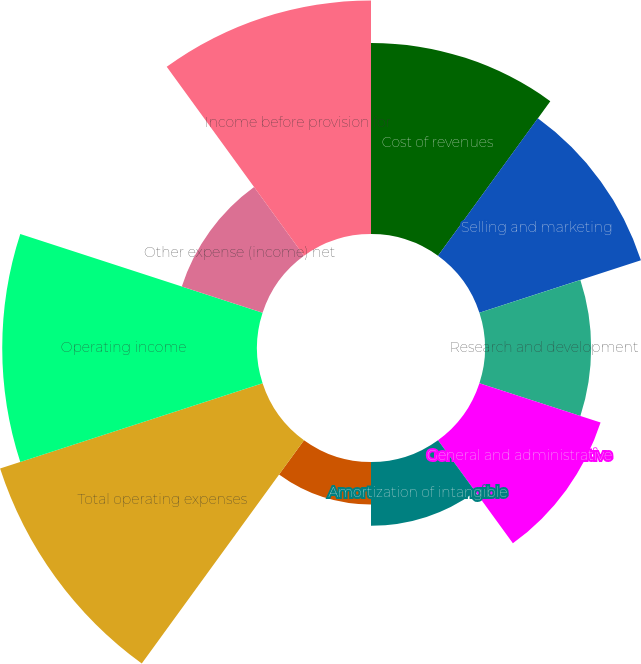Convert chart to OTSL. <chart><loc_0><loc_0><loc_500><loc_500><pie_chart><fcel>Cost of revenues<fcel>Selling and marketing<fcel>Research and development<fcel>General and administrative<fcel>Amortization of intangible<fcel>Depreciation and amortization<fcel>Total operating expenses<fcel>Operating income<fcel>Other expense (income) net<fcel>Income before provision for<nl><fcel>12.33%<fcel>10.96%<fcel>6.85%<fcel>8.22%<fcel>4.11%<fcel>2.74%<fcel>17.81%<fcel>16.44%<fcel>5.48%<fcel>15.07%<nl></chart> 